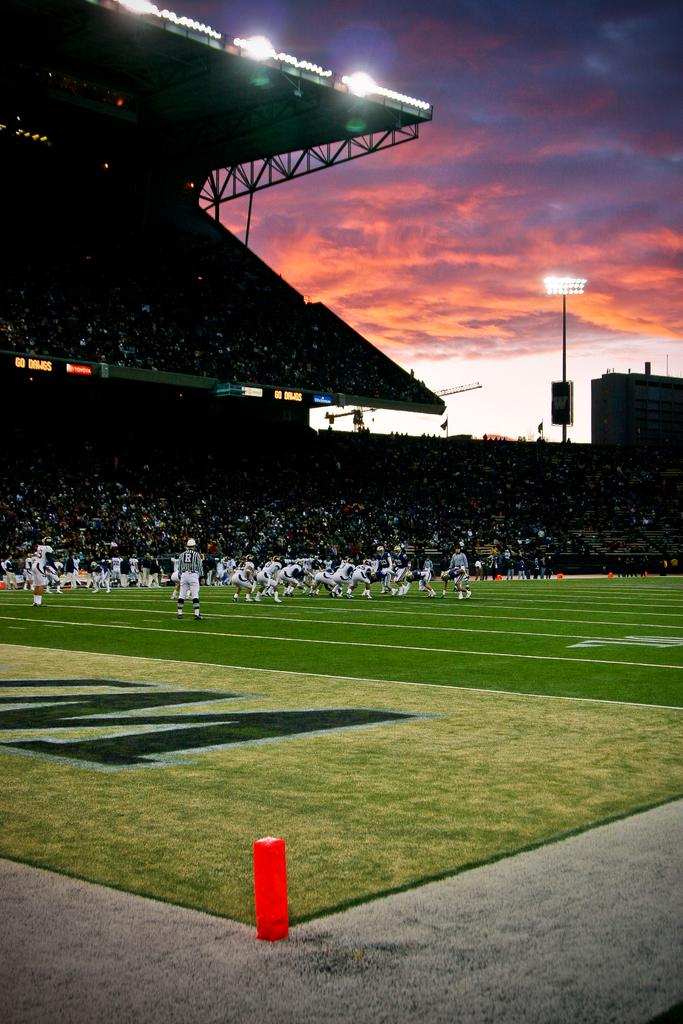What type of structure is visible in the image? There is a stadium in the image. What can be seen inside the stadium? There is a large crowd in the sitting area of the stadium. What is the weather like in the image? The sky is covered with clouds. What hobbies do the people in the crowd have in common? There is no information about the hobbies of the people in the crowd, so it cannot be determined from the image. 